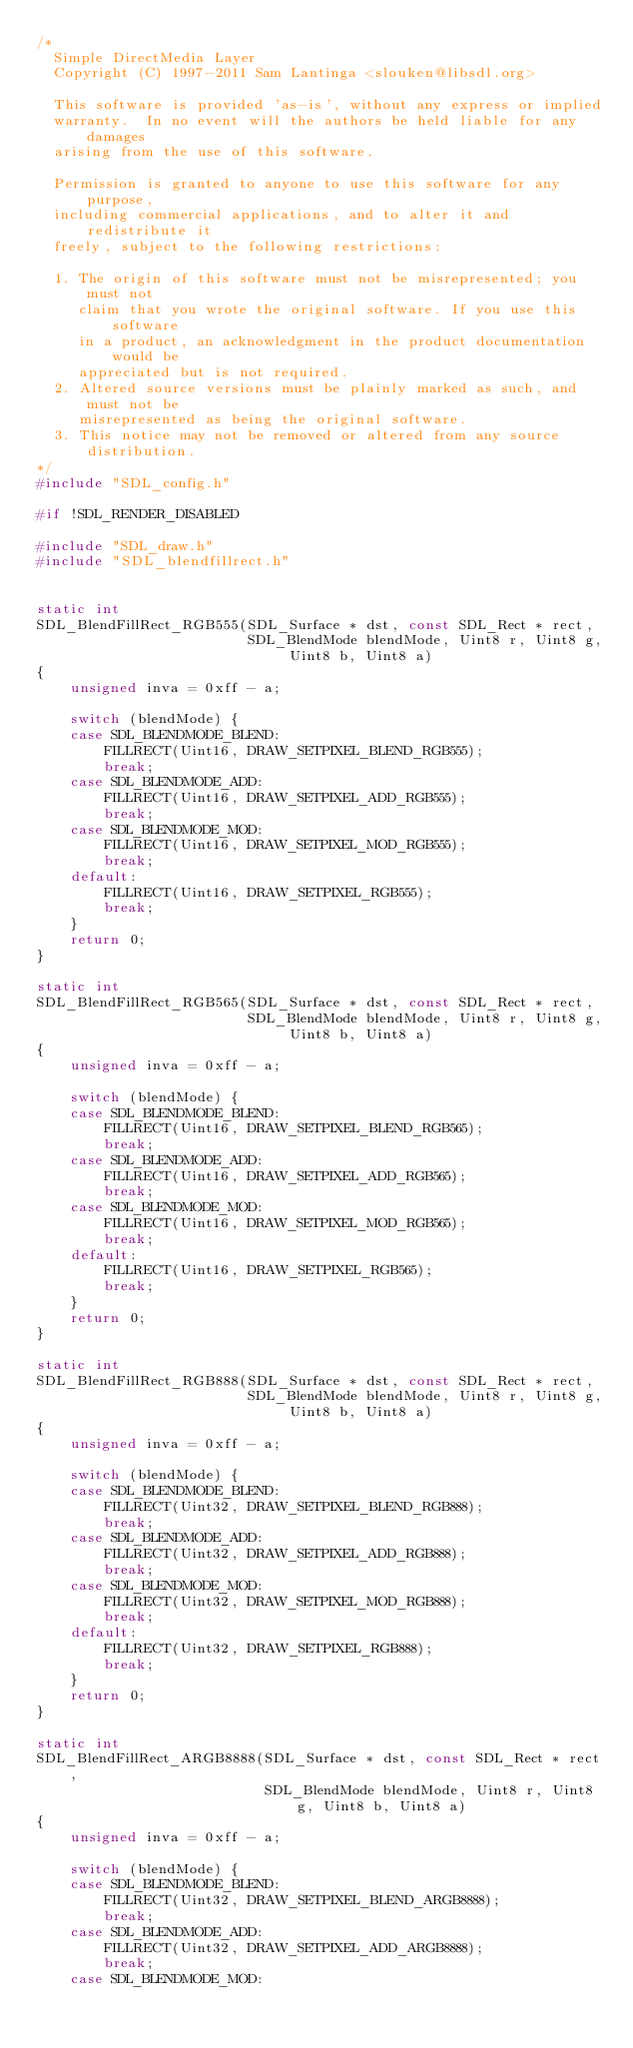<code> <loc_0><loc_0><loc_500><loc_500><_C_>/*
  Simple DirectMedia Layer
  Copyright (C) 1997-2011 Sam Lantinga <slouken@libsdl.org>

  This software is provided 'as-is', without any express or implied
  warranty.  In no event will the authors be held liable for any damages
  arising from the use of this software.

  Permission is granted to anyone to use this software for any purpose,
  including commercial applications, and to alter it and redistribute it
  freely, subject to the following restrictions:

  1. The origin of this software must not be misrepresented; you must not
     claim that you wrote the original software. If you use this software
     in a product, an acknowledgment in the product documentation would be
     appreciated but is not required.
  2. Altered source versions must be plainly marked as such, and must not be
     misrepresented as being the original software.
  3. This notice may not be removed or altered from any source distribution.
*/
#include "SDL_config.h"

#if !SDL_RENDER_DISABLED

#include "SDL_draw.h"
#include "SDL_blendfillrect.h"


static int
SDL_BlendFillRect_RGB555(SDL_Surface * dst, const SDL_Rect * rect,
                         SDL_BlendMode blendMode, Uint8 r, Uint8 g, Uint8 b, Uint8 a)
{
    unsigned inva = 0xff - a;

    switch (blendMode) {
    case SDL_BLENDMODE_BLEND:
        FILLRECT(Uint16, DRAW_SETPIXEL_BLEND_RGB555);
        break;
    case SDL_BLENDMODE_ADD:
        FILLRECT(Uint16, DRAW_SETPIXEL_ADD_RGB555);
        break;
    case SDL_BLENDMODE_MOD:
        FILLRECT(Uint16, DRAW_SETPIXEL_MOD_RGB555);
        break;
    default:
        FILLRECT(Uint16, DRAW_SETPIXEL_RGB555);
        break;
    }
    return 0;
}

static int
SDL_BlendFillRect_RGB565(SDL_Surface * dst, const SDL_Rect * rect,
                         SDL_BlendMode blendMode, Uint8 r, Uint8 g, Uint8 b, Uint8 a)
{
    unsigned inva = 0xff - a;

    switch (blendMode) {
    case SDL_BLENDMODE_BLEND:
        FILLRECT(Uint16, DRAW_SETPIXEL_BLEND_RGB565);
        break;
    case SDL_BLENDMODE_ADD:
        FILLRECT(Uint16, DRAW_SETPIXEL_ADD_RGB565);
        break;
    case SDL_BLENDMODE_MOD:
        FILLRECT(Uint16, DRAW_SETPIXEL_MOD_RGB565);
        break;
    default:
        FILLRECT(Uint16, DRAW_SETPIXEL_RGB565);
        break;
    }
    return 0;
}

static int
SDL_BlendFillRect_RGB888(SDL_Surface * dst, const SDL_Rect * rect,
                         SDL_BlendMode blendMode, Uint8 r, Uint8 g, Uint8 b, Uint8 a)
{
    unsigned inva = 0xff - a;

    switch (blendMode) {
    case SDL_BLENDMODE_BLEND:
        FILLRECT(Uint32, DRAW_SETPIXEL_BLEND_RGB888);
        break;
    case SDL_BLENDMODE_ADD:
        FILLRECT(Uint32, DRAW_SETPIXEL_ADD_RGB888);
        break;
    case SDL_BLENDMODE_MOD:
        FILLRECT(Uint32, DRAW_SETPIXEL_MOD_RGB888);
        break;
    default:
        FILLRECT(Uint32, DRAW_SETPIXEL_RGB888);
        break;
    }
    return 0;
}

static int
SDL_BlendFillRect_ARGB8888(SDL_Surface * dst, const SDL_Rect * rect,
                           SDL_BlendMode blendMode, Uint8 r, Uint8 g, Uint8 b, Uint8 a)
{
    unsigned inva = 0xff - a;

    switch (blendMode) {
    case SDL_BLENDMODE_BLEND:
        FILLRECT(Uint32, DRAW_SETPIXEL_BLEND_ARGB8888);
        break;
    case SDL_BLENDMODE_ADD:
        FILLRECT(Uint32, DRAW_SETPIXEL_ADD_ARGB8888);
        break;
    case SDL_BLENDMODE_MOD:</code> 